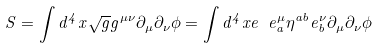Convert formula to latex. <formula><loc_0><loc_0><loc_500><loc_500>S = \int d ^ { 4 } x \sqrt { g } g ^ { \mu \nu } \partial _ { \mu } \partial _ { \nu } \phi = \int d ^ { 4 } x e \ e ^ { \mu } _ { a } \eta ^ { a b } e ^ { \nu } _ { b } \partial _ { \mu } \partial _ { \nu } \phi</formula> 